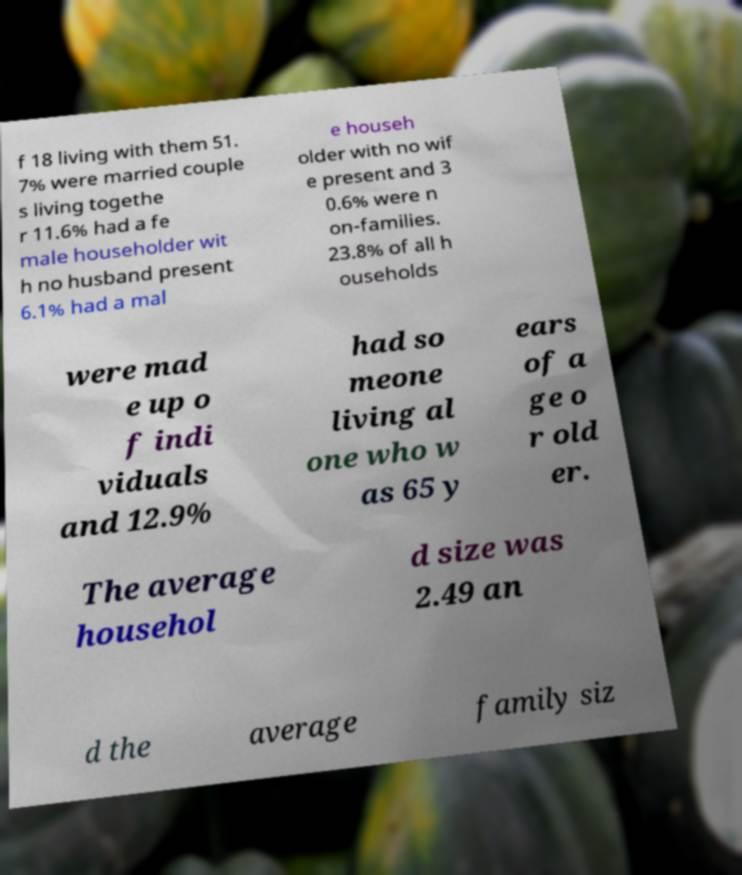Could you assist in decoding the text presented in this image and type it out clearly? f 18 living with them 51. 7% were married couple s living togethe r 11.6% had a fe male householder wit h no husband present 6.1% had a mal e househ older with no wif e present and 3 0.6% were n on-families. 23.8% of all h ouseholds were mad e up o f indi viduals and 12.9% had so meone living al one who w as 65 y ears of a ge o r old er. The average househol d size was 2.49 an d the average family siz 